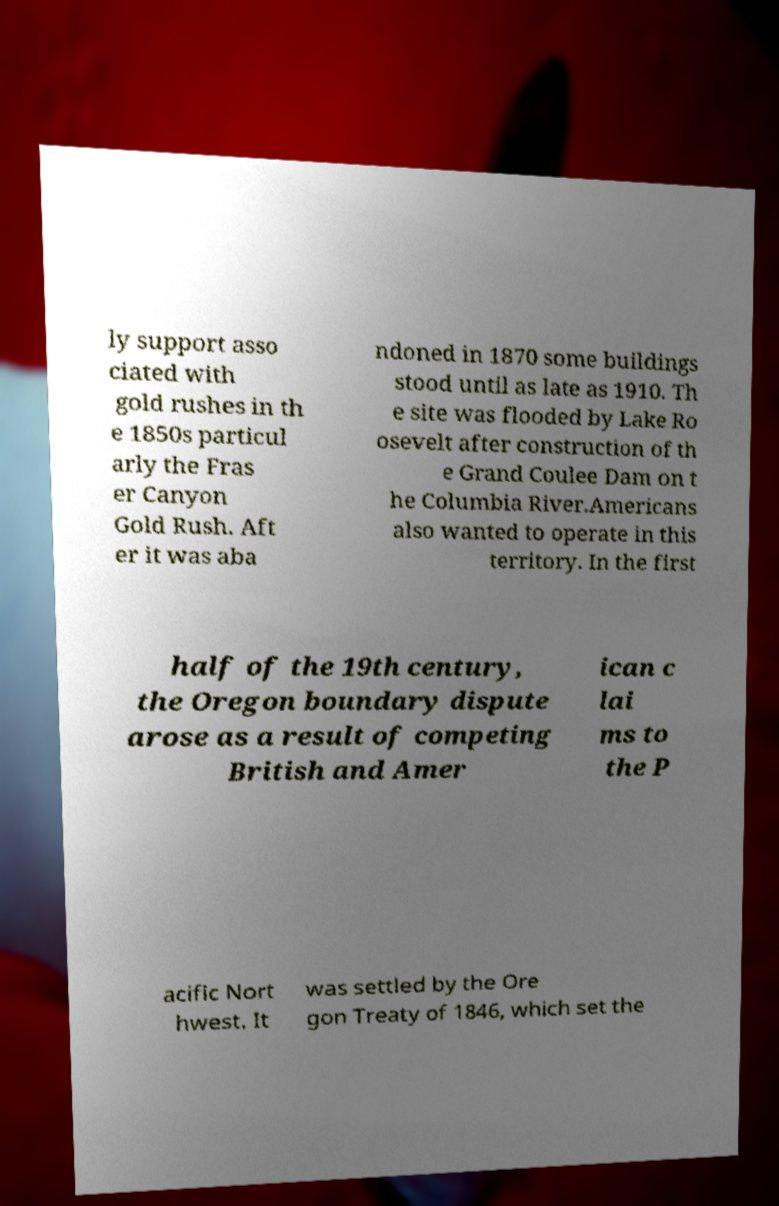I need the written content from this picture converted into text. Can you do that? ly support asso ciated with gold rushes in th e 1850s particul arly the Fras er Canyon Gold Rush. Aft er it was aba ndoned in 1870 some buildings stood until as late as 1910. Th e site was flooded by Lake Ro osevelt after construction of th e Grand Coulee Dam on t he Columbia River.Americans also wanted to operate in this territory. In the first half of the 19th century, the Oregon boundary dispute arose as a result of competing British and Amer ican c lai ms to the P acific Nort hwest. It was settled by the Ore gon Treaty of 1846, which set the 